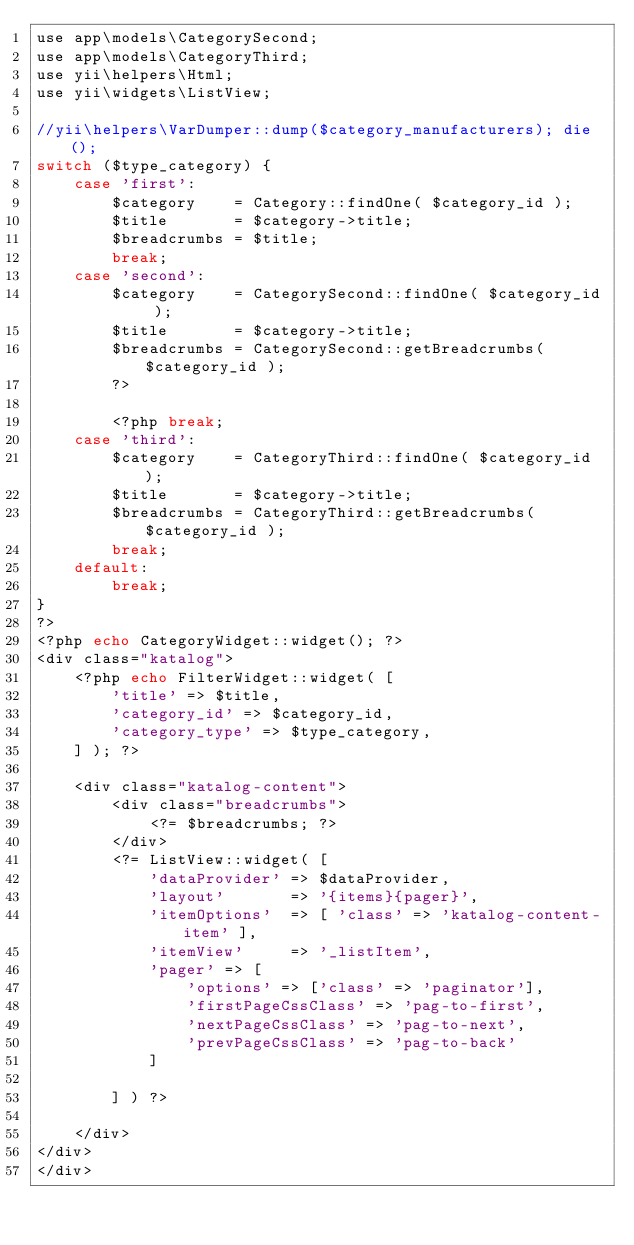Convert code to text. <code><loc_0><loc_0><loc_500><loc_500><_PHP_>use app\models\CategorySecond;
use app\models\CategoryThird;
use yii\helpers\Html;
use yii\widgets\ListView;

//yii\helpers\VarDumper::dump($category_manufacturers); die();
switch ($type_category) {
    case 'first':
        $category    = Category::findOne( $category_id );
        $title       = $category->title;
        $breadcrumbs = $title;
        break;
    case 'second':
        $category    = CategorySecond::findOne( $category_id );
        $title       = $category->title;
        $breadcrumbs = CategorySecond::getBreadcrumbs( $category_id );
        ?>

        <?php break;
    case 'third':
        $category    = CategoryThird::findOne( $category_id );
        $title       = $category->title;
        $breadcrumbs = CategoryThird::getBreadcrumbs( $category_id );
        break;
    default:
        break;
}
?>
<?php echo CategoryWidget::widget(); ?>
<div class="katalog">
    <?php echo FilterWidget::widget( [
        'title' => $title,
        'category_id' => $category_id,
        'category_type' => $type_category,
    ] ); ?>

    <div class="katalog-content">
        <div class="breadcrumbs">
            <?= $breadcrumbs; ?>
        </div>
        <?= ListView::widget( [
            'dataProvider' => $dataProvider,
            'layout'       => '{items}{pager}',
            'itemOptions'  => [ 'class' => 'katalog-content-item' ],
            'itemView'     => '_listItem',
            'pager' => [
                'options' => ['class' => 'paginator'],
                'firstPageCssClass' => 'pag-to-first',
                'nextPageCssClass' => 'pag-to-next',
                'prevPageCssClass' => 'pag-to-back'
            ]

        ] ) ?>

    </div>
</div>
</div>
</code> 